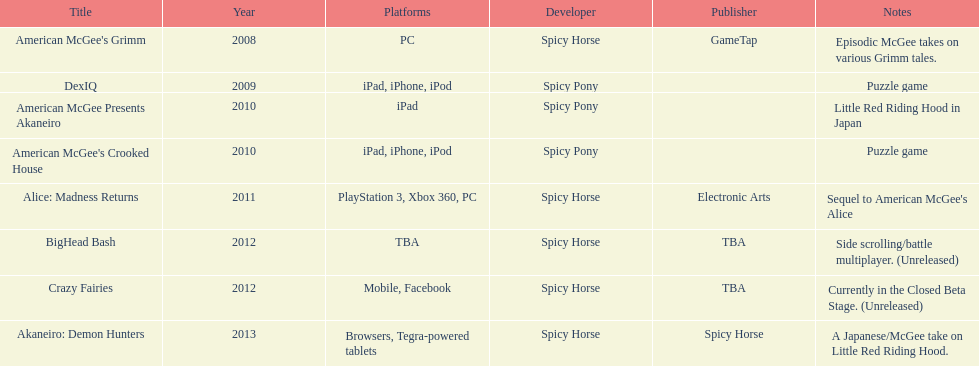What was the only game published by electronic arts? Alice: Madness Returns. 